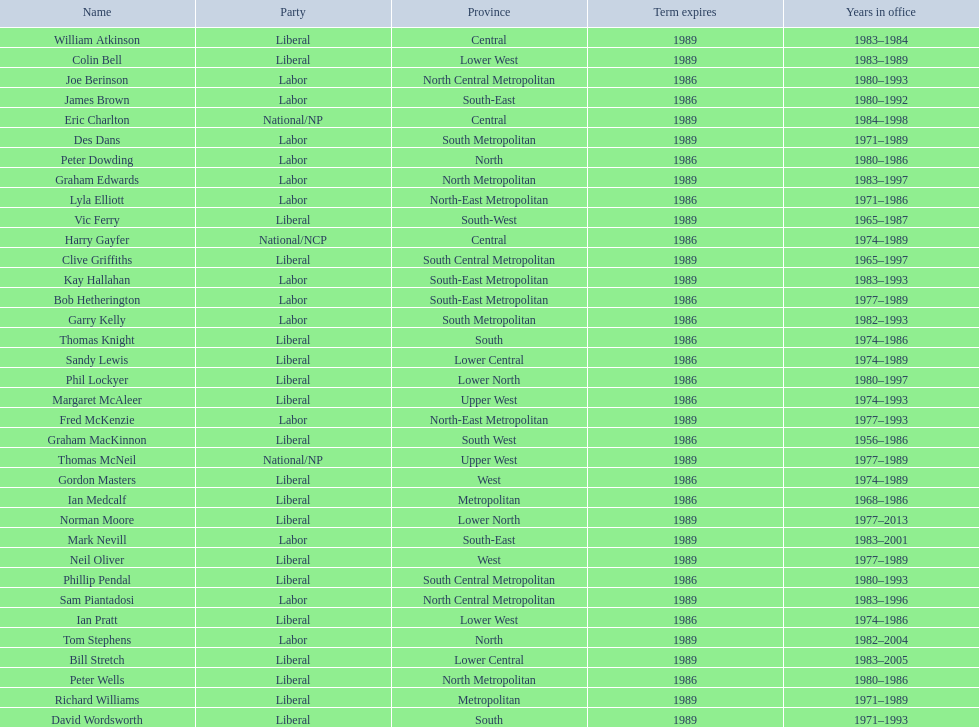What is the complete sum of members whose term finishes in 1989? 9. 